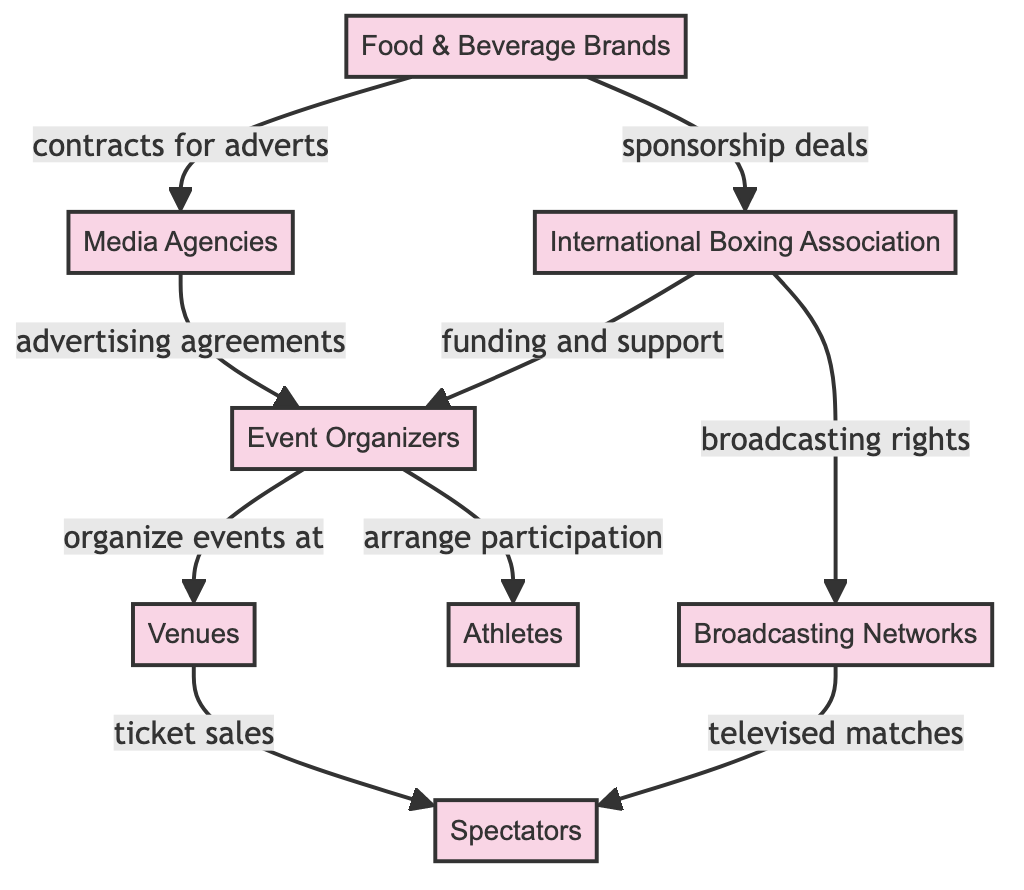What is the first node in the flow? The first node in the flow is "Food & Beverage Brands." It is the starting point of the sponsorship income flow in the diagram.
Answer: Food & Beverage Brands How many nodes are in the diagram? The diagram contains eight nodes: Food & Beverage Brands, Media Agencies, International Boxing Association, Event Organizers, Venues, Broadcasting Networks, Spectators, and Athletes. Counting each of these nodes gives a total of eight.
Answer: 8 What type of agreements do Food & Beverage Brands have with Media Agencies? Food & Beverage Brands have "contracts for adverts" with Media Agencies, indicating the nature of their agreements. This relationship is clearly labeled in the diagram.
Answer: contracts for adverts What is the role of the International Boxing Association in event organization? The International Boxing Association provides "funding and support" to Event Organizers as well as "broadcasting rights" to Broadcasting Networks, which contributes to organizing events for the sport. Thus, they play a crucial role in ensuring events are financially and logistically supported.
Answer: funding and support How do spectators obtain access to the events? Spectators typically obtain access to the events through "ticket sales" from the Venues. This indicates that spectators purchase tickets to watch the events at these locations.
Answer: ticket sales What is the relationship between Media Agencies and Event Organizers? Media Agencies enter into "advertising agreements" with Event Organizers, which suggests Media Agencies pay to promote the events organized by Event Organizers.
Answer: advertising agreements What connects the Broadcasting Networks to Spectators? The connection between Broadcasting Networks and Spectators is through "televised matches." This indicates that the matches organized are shown on television, enabling spectators to view them, possibly without attending in person.
Answer: televised matches Which node receives the contribution for the organization of events? The node that receives contributions for the organization of events is the "Event Organizers." They are shown in the diagram as the node that coordinates and organizes the events using funds and support from other nodes.
Answer: Event Organizers What do Venues provide to the Spectators? Venues provide "ticket sales" to Spectators, allowing them to attend the organized events. This connection shows the transactional flow from the Venues to the audience.
Answer: ticket sales 